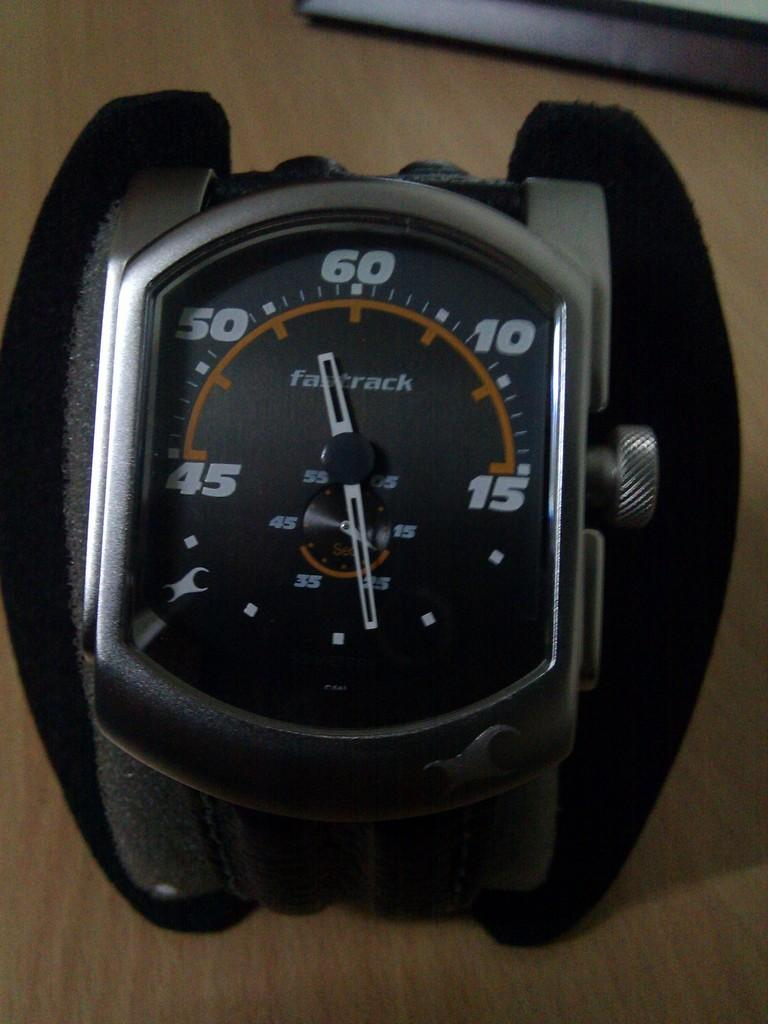<image>
Offer a succinct explanation of the picture presented. A Fastrack watch shows a time between 50 and 60. 